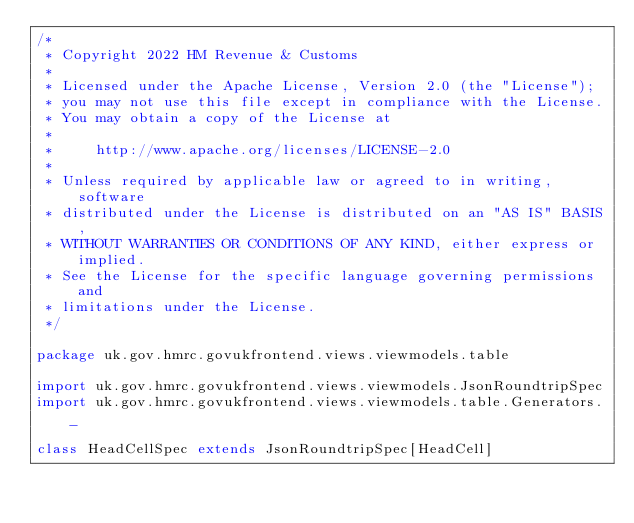Convert code to text. <code><loc_0><loc_0><loc_500><loc_500><_Scala_>/*
 * Copyright 2022 HM Revenue & Customs
 *
 * Licensed under the Apache License, Version 2.0 (the "License");
 * you may not use this file except in compliance with the License.
 * You may obtain a copy of the License at
 *
 *     http://www.apache.org/licenses/LICENSE-2.0
 *
 * Unless required by applicable law or agreed to in writing, software
 * distributed under the License is distributed on an "AS IS" BASIS,
 * WITHOUT WARRANTIES OR CONDITIONS OF ANY KIND, either express or implied.
 * See the License for the specific language governing permissions and
 * limitations under the License.
 */

package uk.gov.hmrc.govukfrontend.views.viewmodels.table

import uk.gov.hmrc.govukfrontend.views.viewmodels.JsonRoundtripSpec
import uk.gov.hmrc.govukfrontend.views.viewmodels.table.Generators._

class HeadCellSpec extends JsonRoundtripSpec[HeadCell]
</code> 